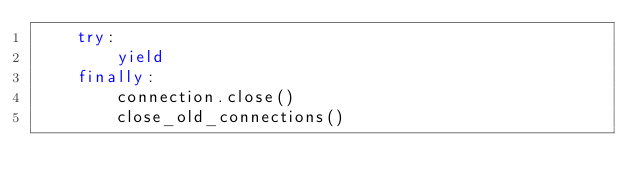<code> <loc_0><loc_0><loc_500><loc_500><_Python_>    try:
        yield
    finally:
        connection.close()
        close_old_connections()
</code> 